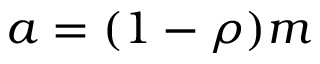Convert formula to latex. <formula><loc_0><loc_0><loc_500><loc_500>a = ( 1 - \rho ) m</formula> 